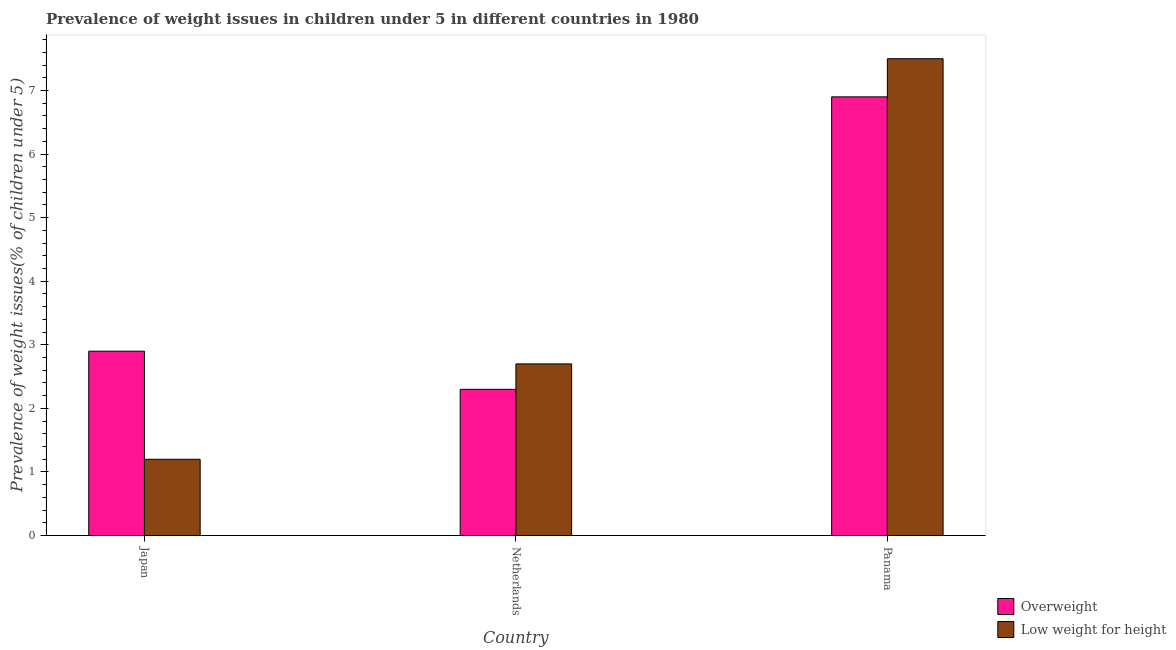How many different coloured bars are there?
Offer a terse response. 2. Are the number of bars per tick equal to the number of legend labels?
Offer a very short reply. Yes. How many bars are there on the 3rd tick from the right?
Make the answer very short. 2. In how many cases, is the number of bars for a given country not equal to the number of legend labels?
Keep it short and to the point. 0. What is the percentage of underweight children in Japan?
Provide a short and direct response. 1.2. Across all countries, what is the maximum percentage of underweight children?
Your response must be concise. 7.5. Across all countries, what is the minimum percentage of overweight children?
Provide a short and direct response. 2.3. In which country was the percentage of overweight children maximum?
Provide a succinct answer. Panama. What is the total percentage of overweight children in the graph?
Your answer should be compact. 12.1. What is the difference between the percentage of underweight children in Netherlands and that in Panama?
Keep it short and to the point. -4.8. What is the difference between the percentage of underweight children in Netherlands and the percentage of overweight children in Panama?
Offer a terse response. -4.2. What is the average percentage of underweight children per country?
Ensure brevity in your answer.  3.8. What is the difference between the percentage of underweight children and percentage of overweight children in Japan?
Offer a terse response. -1.7. In how many countries, is the percentage of overweight children greater than 6.8 %?
Offer a very short reply. 1. What is the ratio of the percentage of overweight children in Japan to that in Netherlands?
Provide a short and direct response. 1.26. Is the percentage of overweight children in Japan less than that in Panama?
Your answer should be compact. Yes. Is the difference between the percentage of overweight children in Japan and Netherlands greater than the difference between the percentage of underweight children in Japan and Netherlands?
Offer a terse response. Yes. What is the difference between the highest and the second highest percentage of overweight children?
Make the answer very short. 4. What is the difference between the highest and the lowest percentage of underweight children?
Provide a short and direct response. 6.3. Is the sum of the percentage of underweight children in Japan and Panama greater than the maximum percentage of overweight children across all countries?
Give a very brief answer. Yes. What does the 1st bar from the left in Netherlands represents?
Give a very brief answer. Overweight. What does the 1st bar from the right in Japan represents?
Provide a succinct answer. Low weight for height. How many countries are there in the graph?
Give a very brief answer. 3. Are the values on the major ticks of Y-axis written in scientific E-notation?
Keep it short and to the point. No. Where does the legend appear in the graph?
Offer a very short reply. Bottom right. How many legend labels are there?
Offer a very short reply. 2. How are the legend labels stacked?
Your response must be concise. Vertical. What is the title of the graph?
Keep it short and to the point. Prevalence of weight issues in children under 5 in different countries in 1980. Does "Goods and services" appear as one of the legend labels in the graph?
Give a very brief answer. No. What is the label or title of the X-axis?
Provide a succinct answer. Country. What is the label or title of the Y-axis?
Your answer should be very brief. Prevalence of weight issues(% of children under 5). What is the Prevalence of weight issues(% of children under 5) of Overweight in Japan?
Offer a terse response. 2.9. What is the Prevalence of weight issues(% of children under 5) of Low weight for height in Japan?
Offer a terse response. 1.2. What is the Prevalence of weight issues(% of children under 5) in Overweight in Netherlands?
Provide a short and direct response. 2.3. What is the Prevalence of weight issues(% of children under 5) in Low weight for height in Netherlands?
Give a very brief answer. 2.7. What is the Prevalence of weight issues(% of children under 5) in Overweight in Panama?
Keep it short and to the point. 6.9. What is the Prevalence of weight issues(% of children under 5) in Low weight for height in Panama?
Your answer should be very brief. 7.5. Across all countries, what is the maximum Prevalence of weight issues(% of children under 5) of Overweight?
Your answer should be compact. 6.9. Across all countries, what is the minimum Prevalence of weight issues(% of children under 5) in Overweight?
Your answer should be very brief. 2.3. Across all countries, what is the minimum Prevalence of weight issues(% of children under 5) of Low weight for height?
Ensure brevity in your answer.  1.2. What is the total Prevalence of weight issues(% of children under 5) in Low weight for height in the graph?
Your answer should be compact. 11.4. What is the difference between the Prevalence of weight issues(% of children under 5) of Overweight in Japan and that in Netherlands?
Provide a succinct answer. 0.6. What is the difference between the Prevalence of weight issues(% of children under 5) of Low weight for height in Japan and that in Netherlands?
Your answer should be compact. -1.5. What is the difference between the Prevalence of weight issues(% of children under 5) of Overweight in Netherlands and that in Panama?
Your response must be concise. -4.6. What is the difference between the Prevalence of weight issues(% of children under 5) in Low weight for height in Netherlands and that in Panama?
Ensure brevity in your answer.  -4.8. What is the difference between the Prevalence of weight issues(% of children under 5) of Overweight in Japan and the Prevalence of weight issues(% of children under 5) of Low weight for height in Netherlands?
Provide a short and direct response. 0.2. What is the average Prevalence of weight issues(% of children under 5) of Overweight per country?
Provide a short and direct response. 4.03. What is the average Prevalence of weight issues(% of children under 5) of Low weight for height per country?
Your answer should be compact. 3.8. What is the difference between the Prevalence of weight issues(% of children under 5) in Overweight and Prevalence of weight issues(% of children under 5) in Low weight for height in Panama?
Your answer should be compact. -0.6. What is the ratio of the Prevalence of weight issues(% of children under 5) of Overweight in Japan to that in Netherlands?
Provide a short and direct response. 1.26. What is the ratio of the Prevalence of weight issues(% of children under 5) of Low weight for height in Japan to that in Netherlands?
Your answer should be compact. 0.44. What is the ratio of the Prevalence of weight issues(% of children under 5) in Overweight in Japan to that in Panama?
Provide a short and direct response. 0.42. What is the ratio of the Prevalence of weight issues(% of children under 5) of Low weight for height in Japan to that in Panama?
Make the answer very short. 0.16. What is the ratio of the Prevalence of weight issues(% of children under 5) of Low weight for height in Netherlands to that in Panama?
Offer a very short reply. 0.36. What is the difference between the highest and the lowest Prevalence of weight issues(% of children under 5) of Low weight for height?
Your response must be concise. 6.3. 